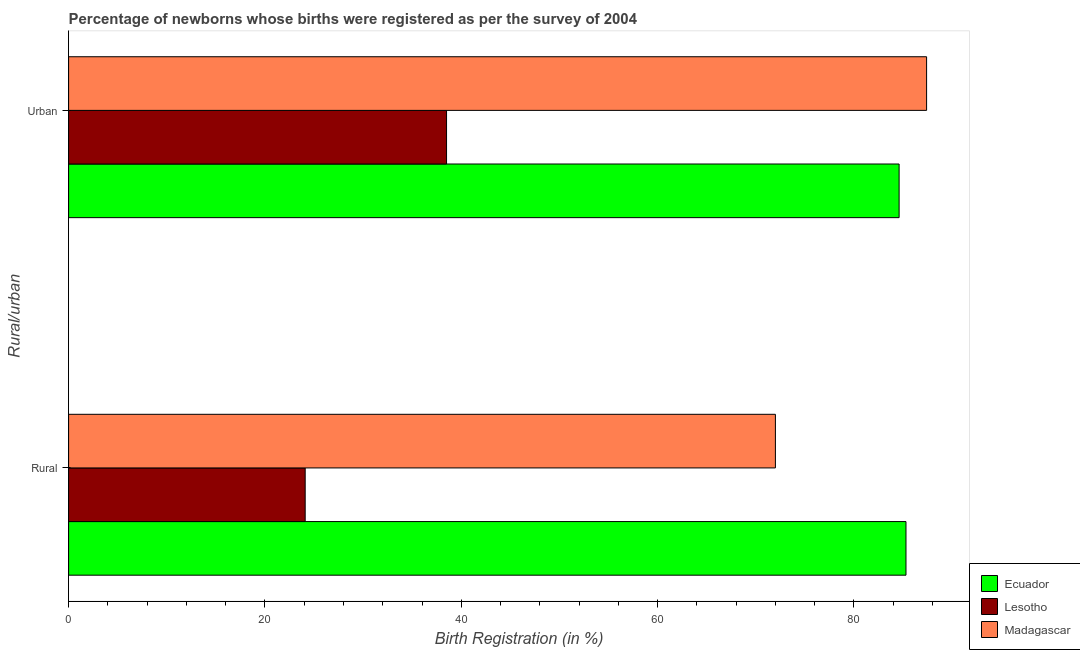Are the number of bars per tick equal to the number of legend labels?
Provide a short and direct response. Yes. What is the label of the 2nd group of bars from the top?
Provide a succinct answer. Rural. What is the urban birth registration in Lesotho?
Your answer should be very brief. 38.5. Across all countries, what is the maximum urban birth registration?
Your response must be concise. 87.4. Across all countries, what is the minimum urban birth registration?
Provide a succinct answer. 38.5. In which country was the rural birth registration maximum?
Make the answer very short. Ecuador. In which country was the urban birth registration minimum?
Offer a terse response. Lesotho. What is the total rural birth registration in the graph?
Make the answer very short. 181.4. What is the difference between the urban birth registration in Ecuador and that in Madagascar?
Keep it short and to the point. -2.8. What is the difference between the urban birth registration in Lesotho and the rural birth registration in Ecuador?
Make the answer very short. -46.8. What is the average urban birth registration per country?
Provide a short and direct response. 70.17. What is the difference between the rural birth registration and urban birth registration in Madagascar?
Your answer should be very brief. -15.4. What is the ratio of the rural birth registration in Madagascar to that in Ecuador?
Your response must be concise. 0.84. Is the urban birth registration in Lesotho less than that in Madagascar?
Ensure brevity in your answer.  Yes. In how many countries, is the urban birth registration greater than the average urban birth registration taken over all countries?
Your answer should be very brief. 2. What does the 3rd bar from the top in Urban represents?
Your response must be concise. Ecuador. What does the 3rd bar from the bottom in Urban represents?
Your answer should be compact. Madagascar. How many bars are there?
Keep it short and to the point. 6. Are all the bars in the graph horizontal?
Make the answer very short. Yes. What is the difference between two consecutive major ticks on the X-axis?
Make the answer very short. 20. Does the graph contain any zero values?
Provide a succinct answer. No. Does the graph contain grids?
Provide a succinct answer. No. Where does the legend appear in the graph?
Keep it short and to the point. Bottom right. What is the title of the graph?
Keep it short and to the point. Percentage of newborns whose births were registered as per the survey of 2004. What is the label or title of the X-axis?
Provide a short and direct response. Birth Registration (in %). What is the label or title of the Y-axis?
Provide a succinct answer. Rural/urban. What is the Birth Registration (in %) of Ecuador in Rural?
Ensure brevity in your answer.  85.3. What is the Birth Registration (in %) of Lesotho in Rural?
Keep it short and to the point. 24.1. What is the Birth Registration (in %) in Madagascar in Rural?
Provide a short and direct response. 72. What is the Birth Registration (in %) of Ecuador in Urban?
Your answer should be compact. 84.6. What is the Birth Registration (in %) in Lesotho in Urban?
Provide a succinct answer. 38.5. What is the Birth Registration (in %) in Madagascar in Urban?
Your answer should be very brief. 87.4. Across all Rural/urban, what is the maximum Birth Registration (in %) in Ecuador?
Your answer should be compact. 85.3. Across all Rural/urban, what is the maximum Birth Registration (in %) in Lesotho?
Provide a succinct answer. 38.5. Across all Rural/urban, what is the maximum Birth Registration (in %) in Madagascar?
Provide a short and direct response. 87.4. Across all Rural/urban, what is the minimum Birth Registration (in %) of Ecuador?
Make the answer very short. 84.6. Across all Rural/urban, what is the minimum Birth Registration (in %) in Lesotho?
Provide a short and direct response. 24.1. What is the total Birth Registration (in %) of Ecuador in the graph?
Provide a short and direct response. 169.9. What is the total Birth Registration (in %) in Lesotho in the graph?
Your answer should be compact. 62.6. What is the total Birth Registration (in %) of Madagascar in the graph?
Provide a short and direct response. 159.4. What is the difference between the Birth Registration (in %) of Ecuador in Rural and that in Urban?
Your answer should be very brief. 0.7. What is the difference between the Birth Registration (in %) in Lesotho in Rural and that in Urban?
Your answer should be very brief. -14.4. What is the difference between the Birth Registration (in %) in Madagascar in Rural and that in Urban?
Your answer should be compact. -15.4. What is the difference between the Birth Registration (in %) of Ecuador in Rural and the Birth Registration (in %) of Lesotho in Urban?
Provide a short and direct response. 46.8. What is the difference between the Birth Registration (in %) in Lesotho in Rural and the Birth Registration (in %) in Madagascar in Urban?
Keep it short and to the point. -63.3. What is the average Birth Registration (in %) of Ecuador per Rural/urban?
Provide a short and direct response. 84.95. What is the average Birth Registration (in %) in Lesotho per Rural/urban?
Your answer should be very brief. 31.3. What is the average Birth Registration (in %) in Madagascar per Rural/urban?
Offer a terse response. 79.7. What is the difference between the Birth Registration (in %) in Ecuador and Birth Registration (in %) in Lesotho in Rural?
Your answer should be very brief. 61.2. What is the difference between the Birth Registration (in %) in Lesotho and Birth Registration (in %) in Madagascar in Rural?
Your response must be concise. -47.9. What is the difference between the Birth Registration (in %) of Ecuador and Birth Registration (in %) of Lesotho in Urban?
Ensure brevity in your answer.  46.1. What is the difference between the Birth Registration (in %) in Ecuador and Birth Registration (in %) in Madagascar in Urban?
Make the answer very short. -2.8. What is the difference between the Birth Registration (in %) in Lesotho and Birth Registration (in %) in Madagascar in Urban?
Your response must be concise. -48.9. What is the ratio of the Birth Registration (in %) in Ecuador in Rural to that in Urban?
Ensure brevity in your answer.  1.01. What is the ratio of the Birth Registration (in %) in Lesotho in Rural to that in Urban?
Ensure brevity in your answer.  0.63. What is the ratio of the Birth Registration (in %) in Madagascar in Rural to that in Urban?
Give a very brief answer. 0.82. What is the difference between the highest and the second highest Birth Registration (in %) of Lesotho?
Provide a short and direct response. 14.4. What is the difference between the highest and the lowest Birth Registration (in %) in Ecuador?
Provide a succinct answer. 0.7. What is the difference between the highest and the lowest Birth Registration (in %) of Lesotho?
Provide a short and direct response. 14.4. 